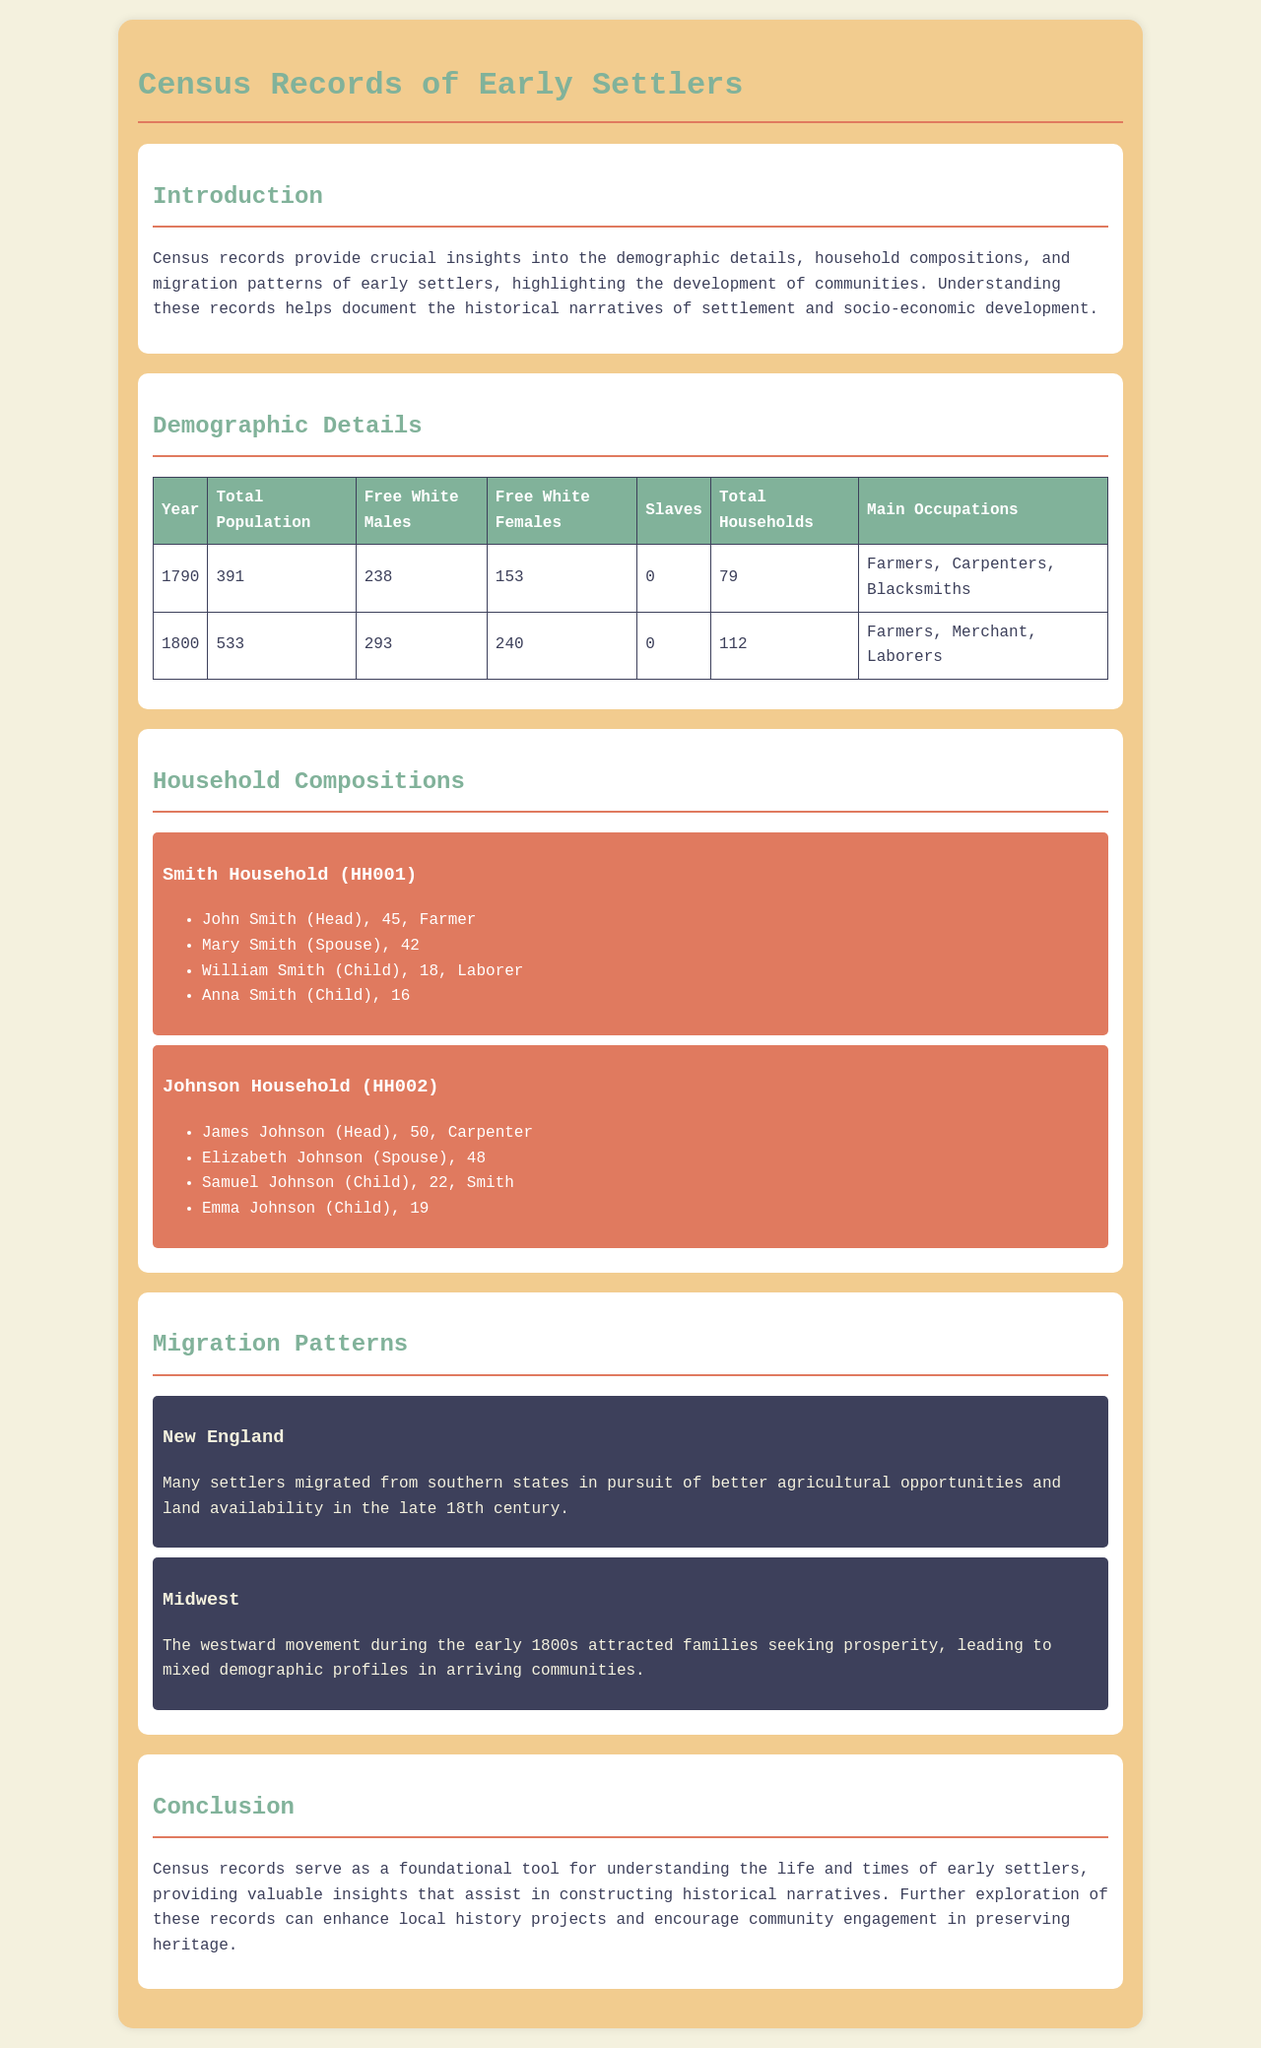what was the total population in 1790? The total population in 1790 is found in the table under "Total Population" for that year, which is 391.
Answer: 391 how many total households were recorded in 1800? The total households recorded in 1800 is found in the table under "Total Households" for that year, which is 112.
Answer: 112 who is the head of the Smith Household? The head of the Smith Household is listed as John Smith in the household composition section.
Answer: John Smith what occupation was mentioned for the Johnson Household? The occupation for the head of the Johnson Household, James Johnson, is stated as Carpenter.
Answer: Carpenter which region experienced westward migration in the early 1800s? The document mentions that the Midwest experienced migration during this period, specifically highlighting families seeking prosperity.
Answer: Midwest how many free white females were there in 1800? The number of free white females in 1800 can be found in the demographic details table, indicating 240.
Answer: 240 what are the main occupations listed for 1790? The main occupations for 1790 are listed in the table, which includes Farmers, Carpenters, and Blacksmiths.
Answer: Farmers, Carpenters, Blacksmiths what is the primary purpose of census records as outlined in the document? The primary purpose of census records is detailed in the introduction, describing their role in providing insights into various aspects concerning early settlers.
Answer: Insights into demographic details, household compositions, and migration patterns 